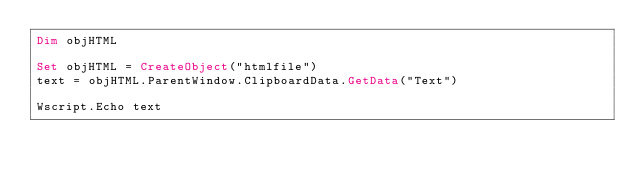Convert code to text. <code><loc_0><loc_0><loc_500><loc_500><_VisualBasic_>Dim objHTML

Set objHTML = CreateObject("htmlfile")
text = objHTML.ParentWindow.ClipboardData.GetData("Text")

Wscript.Echo text
</code> 